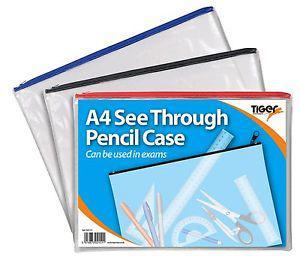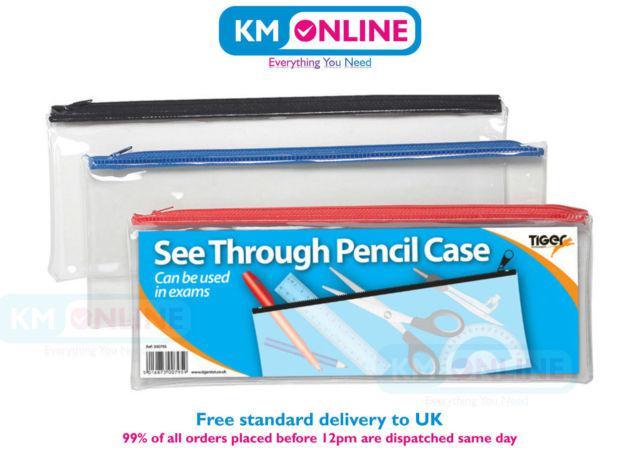The first image is the image on the left, the second image is the image on the right. Analyze the images presented: Is the assertion "There are three pencil cases in at least one of the images." valid? Answer yes or no. Yes. The first image is the image on the left, the second image is the image on the right. Assess this claim about the two images: "One pencil bag has a design.". Correct or not? Answer yes or no. No. 